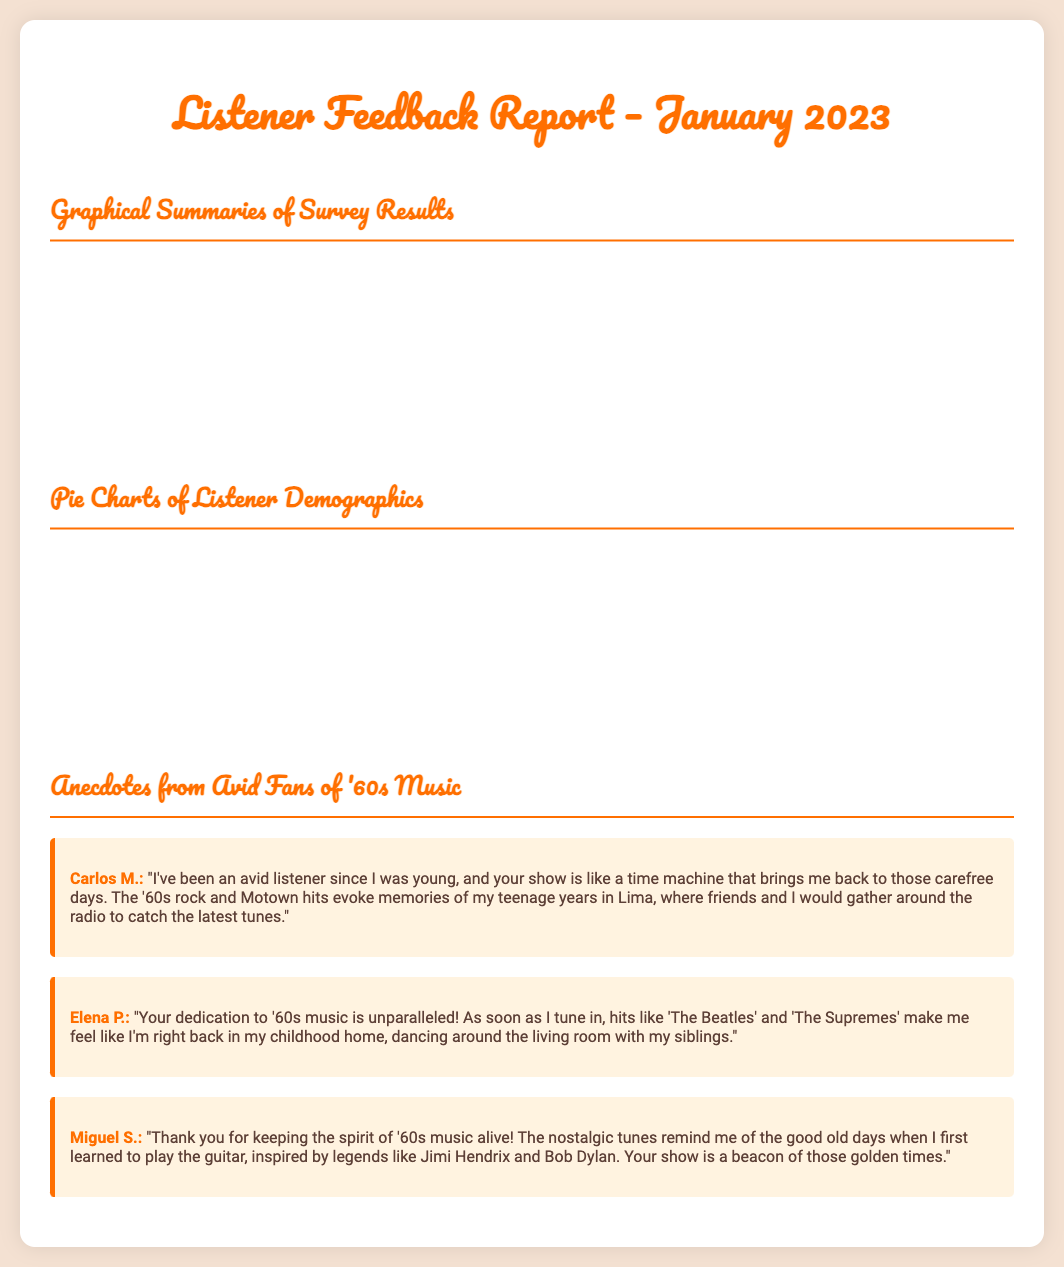what is the report title? The report title is presented at the top of the document, indicating the focus on listener feedback for a specific month.
Answer: Listener Feedback Report – January 2023 what percentage of listeners prefer Classic Rock? The document provides a bar chart showing the distribution of favorite '60s music genres and the specific values for each genre.
Answer: 45 who shared an anecdote about dancing with siblings? The anecdotes section includes personal stories from listeners, one of which mentions dancing with siblings.
Answer: Elena P what is the age group with the highest percentage of listeners? The pie chart in the demographics section illustrates the age distribution of listeners.
Answer: 55+ how many months of listener satisfaction data are presented? The line chart shows the trend of listener satisfaction over several months throughout the year.
Answer: 12 which platform is the most popular for listening? The pie chart regarding listening platforms clearly shows the percentage distribution of listeners across different platforms.
Answer: Radio what is the lowest figure in the listener satisfaction data? The satisfaction data is represented in a line chart, indicating the minimum value over time.
Answer: 78 how many tribes of music genres are represented in the report? The bar chart categorizes favorite genres into specific types relevant to '60s music.
Answer: 5 